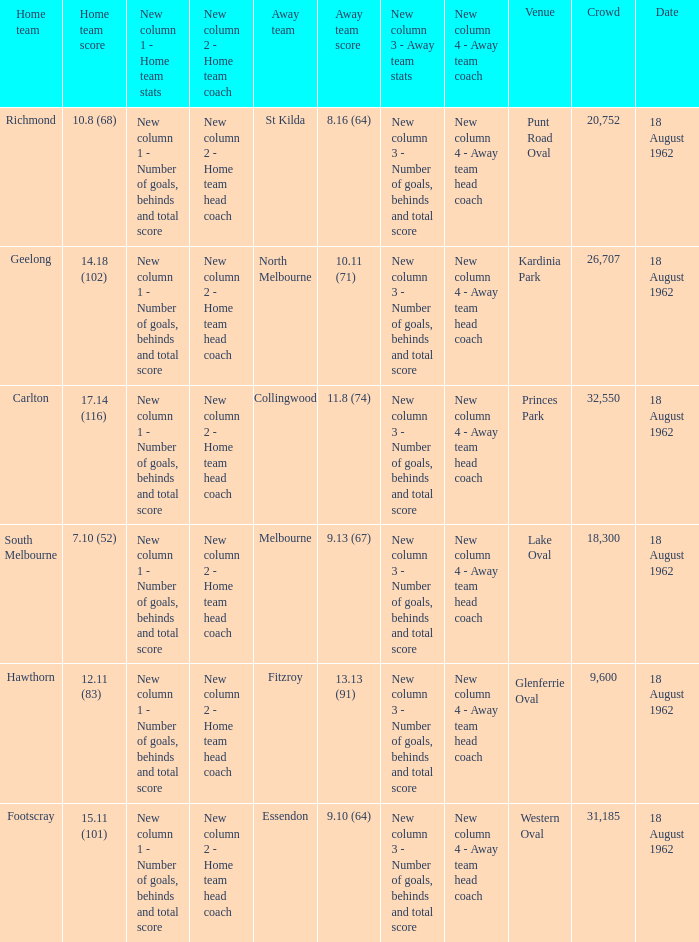In which setting where the home team recorded 1 None. 